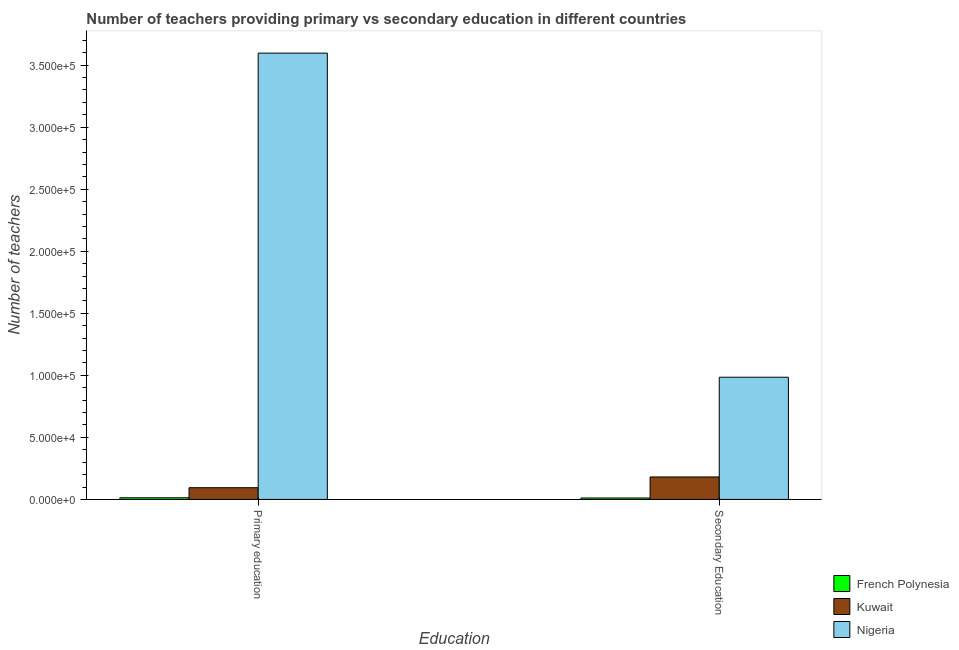How many different coloured bars are there?
Offer a terse response. 3. How many bars are there on the 2nd tick from the left?
Your answer should be very brief. 3. How many bars are there on the 1st tick from the right?
Your answer should be very brief. 3. What is the label of the 2nd group of bars from the left?
Provide a succinct answer. Secondary Education. What is the number of secondary teachers in French Polynesia?
Your response must be concise. 1166. Across all countries, what is the maximum number of primary teachers?
Give a very brief answer. 3.60e+05. Across all countries, what is the minimum number of secondary teachers?
Offer a terse response. 1166. In which country was the number of secondary teachers maximum?
Offer a very short reply. Nigeria. In which country was the number of secondary teachers minimum?
Your response must be concise. French Polynesia. What is the total number of primary teachers in the graph?
Make the answer very short. 3.70e+05. What is the difference between the number of primary teachers in Nigeria and that in French Polynesia?
Offer a terse response. 3.58e+05. What is the difference between the number of secondary teachers in French Polynesia and the number of primary teachers in Nigeria?
Your response must be concise. -3.59e+05. What is the average number of primary teachers per country?
Make the answer very short. 1.23e+05. What is the difference between the number of primary teachers and number of secondary teachers in Nigeria?
Your answer should be compact. 2.61e+05. What is the ratio of the number of primary teachers in French Polynesia to that in Kuwait?
Your answer should be compact. 0.14. What does the 2nd bar from the left in Primary education represents?
Your answer should be compact. Kuwait. What does the 3rd bar from the right in Secondary Education represents?
Give a very brief answer. French Polynesia. Are the values on the major ticks of Y-axis written in scientific E-notation?
Ensure brevity in your answer.  Yes. Does the graph contain any zero values?
Make the answer very short. No. Does the graph contain grids?
Make the answer very short. No. How many legend labels are there?
Your answer should be compact. 3. How are the legend labels stacked?
Your answer should be compact. Vertical. What is the title of the graph?
Keep it short and to the point. Number of teachers providing primary vs secondary education in different countries. Does "Korea (Democratic)" appear as one of the legend labels in the graph?
Your answer should be compact. No. What is the label or title of the X-axis?
Offer a very short reply. Education. What is the label or title of the Y-axis?
Ensure brevity in your answer.  Number of teachers. What is the Number of teachers in French Polynesia in Primary education?
Your answer should be compact. 1337. What is the Number of teachers in Kuwait in Primary education?
Provide a short and direct response. 9448. What is the Number of teachers of Nigeria in Primary education?
Ensure brevity in your answer.  3.60e+05. What is the Number of teachers in French Polynesia in Secondary Education?
Your answer should be compact. 1166. What is the Number of teachers in Kuwait in Secondary Education?
Make the answer very short. 1.81e+04. What is the Number of teachers of Nigeria in Secondary Education?
Give a very brief answer. 9.85e+04. Across all Education, what is the maximum Number of teachers in French Polynesia?
Make the answer very short. 1337. Across all Education, what is the maximum Number of teachers in Kuwait?
Provide a short and direct response. 1.81e+04. Across all Education, what is the maximum Number of teachers in Nigeria?
Ensure brevity in your answer.  3.60e+05. Across all Education, what is the minimum Number of teachers in French Polynesia?
Offer a very short reply. 1166. Across all Education, what is the minimum Number of teachers of Kuwait?
Provide a succinct answer. 9448. Across all Education, what is the minimum Number of teachers of Nigeria?
Offer a terse response. 9.85e+04. What is the total Number of teachers in French Polynesia in the graph?
Give a very brief answer. 2503. What is the total Number of teachers of Kuwait in the graph?
Offer a very short reply. 2.76e+04. What is the total Number of teachers of Nigeria in the graph?
Make the answer very short. 4.58e+05. What is the difference between the Number of teachers in French Polynesia in Primary education and that in Secondary Education?
Give a very brief answer. 171. What is the difference between the Number of teachers of Kuwait in Primary education and that in Secondary Education?
Provide a succinct answer. -8658. What is the difference between the Number of teachers of Nigeria in Primary education and that in Secondary Education?
Offer a terse response. 2.61e+05. What is the difference between the Number of teachers of French Polynesia in Primary education and the Number of teachers of Kuwait in Secondary Education?
Ensure brevity in your answer.  -1.68e+04. What is the difference between the Number of teachers of French Polynesia in Primary education and the Number of teachers of Nigeria in Secondary Education?
Your answer should be very brief. -9.72e+04. What is the difference between the Number of teachers of Kuwait in Primary education and the Number of teachers of Nigeria in Secondary Education?
Keep it short and to the point. -8.90e+04. What is the average Number of teachers of French Polynesia per Education?
Offer a terse response. 1251.5. What is the average Number of teachers of Kuwait per Education?
Your answer should be compact. 1.38e+04. What is the average Number of teachers of Nigeria per Education?
Your answer should be very brief. 2.29e+05. What is the difference between the Number of teachers in French Polynesia and Number of teachers in Kuwait in Primary education?
Offer a terse response. -8111. What is the difference between the Number of teachers of French Polynesia and Number of teachers of Nigeria in Primary education?
Ensure brevity in your answer.  -3.58e+05. What is the difference between the Number of teachers in Kuwait and Number of teachers in Nigeria in Primary education?
Provide a short and direct response. -3.50e+05. What is the difference between the Number of teachers in French Polynesia and Number of teachers in Kuwait in Secondary Education?
Give a very brief answer. -1.69e+04. What is the difference between the Number of teachers in French Polynesia and Number of teachers in Nigeria in Secondary Education?
Keep it short and to the point. -9.73e+04. What is the difference between the Number of teachers in Kuwait and Number of teachers in Nigeria in Secondary Education?
Your response must be concise. -8.04e+04. What is the ratio of the Number of teachers in French Polynesia in Primary education to that in Secondary Education?
Offer a very short reply. 1.15. What is the ratio of the Number of teachers of Kuwait in Primary education to that in Secondary Education?
Offer a very short reply. 0.52. What is the ratio of the Number of teachers in Nigeria in Primary education to that in Secondary Education?
Give a very brief answer. 3.65. What is the difference between the highest and the second highest Number of teachers in French Polynesia?
Your answer should be very brief. 171. What is the difference between the highest and the second highest Number of teachers of Kuwait?
Your response must be concise. 8658. What is the difference between the highest and the second highest Number of teachers of Nigeria?
Offer a terse response. 2.61e+05. What is the difference between the highest and the lowest Number of teachers in French Polynesia?
Give a very brief answer. 171. What is the difference between the highest and the lowest Number of teachers of Kuwait?
Your answer should be very brief. 8658. What is the difference between the highest and the lowest Number of teachers of Nigeria?
Give a very brief answer. 2.61e+05. 